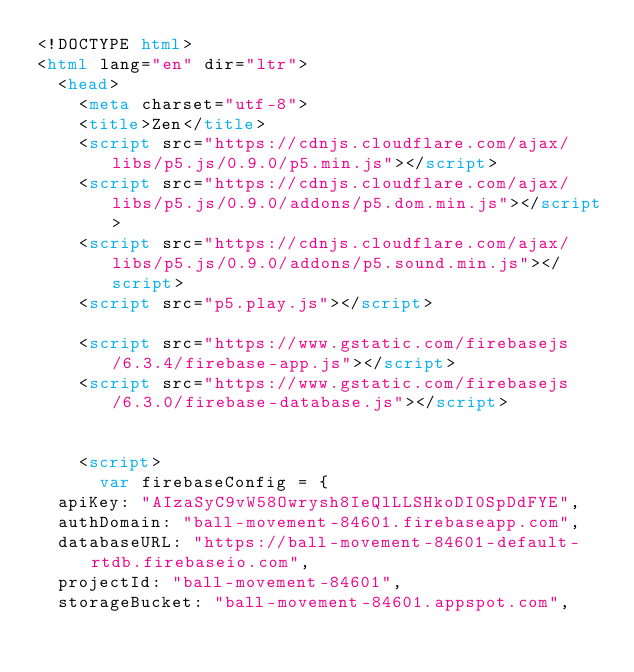Convert code to text. <code><loc_0><loc_0><loc_500><loc_500><_HTML_><!DOCTYPE html>
<html lang="en" dir="ltr">
  <head>
    <meta charset="utf-8">
    <title>Zen</title>
    <script src="https://cdnjs.cloudflare.com/ajax/libs/p5.js/0.9.0/p5.min.js"></script>
    <script src="https://cdnjs.cloudflare.com/ajax/libs/p5.js/0.9.0/addons/p5.dom.min.js"></script>
    <script src="https://cdnjs.cloudflare.com/ajax/libs/p5.js/0.9.0/addons/p5.sound.min.js"></script>
    <script src="p5.play.js"></script>

    <script src="https://www.gstatic.com/firebasejs/6.3.4/firebase-app.js"></script>
    <script src="https://www.gstatic.com/firebasejs/6.3.0/firebase-database.js"></script>


    <script>
      var firebaseConfig = {
  apiKey: "AIzaSyC9vW58Owrysh8IeQlLLSHkoDI0SpDdFYE",
  authDomain: "ball-movement-84601.firebaseapp.com",
  databaseURL: "https://ball-movement-84601-default-rtdb.firebaseio.com",
  projectId: "ball-movement-84601",
  storageBucket: "ball-movement-84601.appspot.com",</code> 